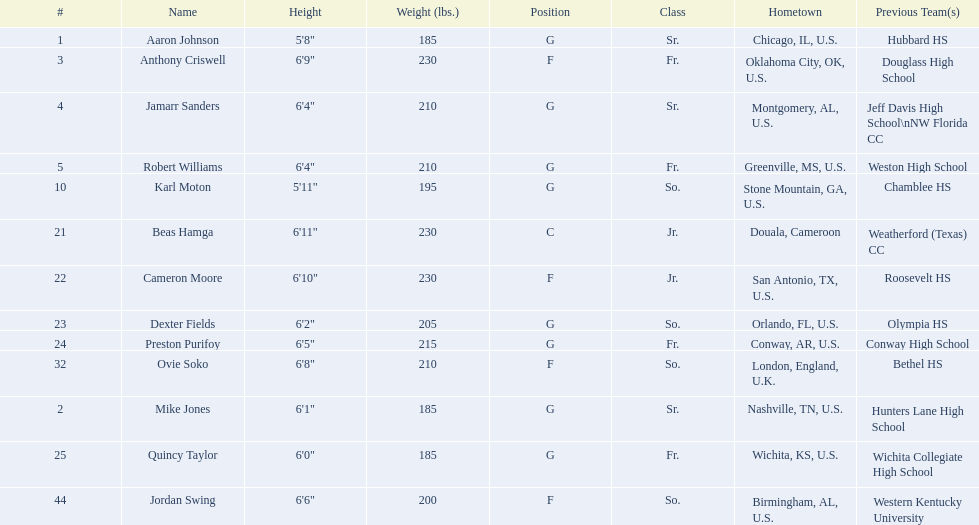Who are all the participants? Aaron Johnson, Anthony Criswell, Jamarr Sanders, Robert Williams, Karl Moton, Beas Hamga, Cameron Moore, Dexter Fields, Preston Purifoy, Ovie Soko, Mike Jones, Quincy Taylor, Jordan Swing. Which participants are from a nation outside the u.s.? Beas Hamga, Ovie Soko. Besides soko, who else is not from the u.s.? Beas Hamga. 